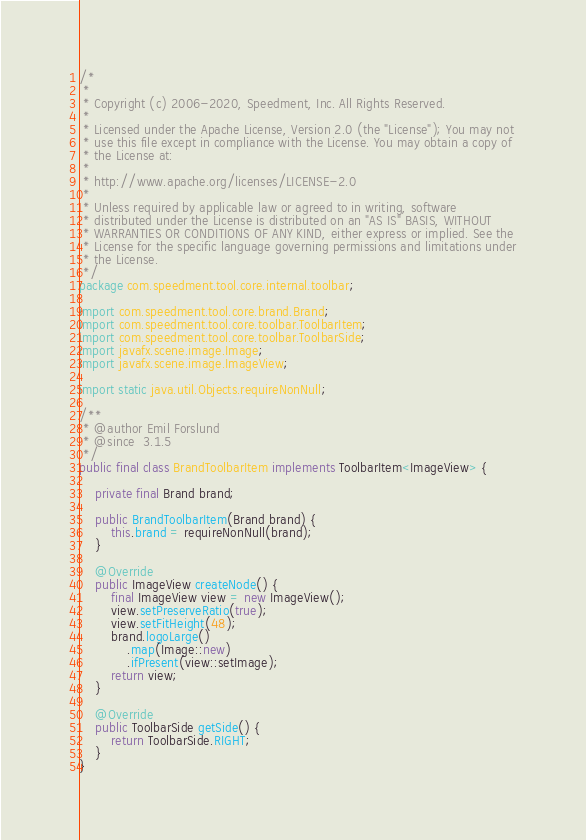<code> <loc_0><loc_0><loc_500><loc_500><_Java_>/*
 *
 * Copyright (c) 2006-2020, Speedment, Inc. All Rights Reserved.
 *
 * Licensed under the Apache License, Version 2.0 (the "License"); You may not
 * use this file except in compliance with the License. You may obtain a copy of
 * the License at:
 *
 * http://www.apache.org/licenses/LICENSE-2.0
 *
 * Unless required by applicable law or agreed to in writing, software
 * distributed under the License is distributed on an "AS IS" BASIS, WITHOUT
 * WARRANTIES OR CONDITIONS OF ANY KIND, either express or implied. See the
 * License for the specific language governing permissions and limitations under
 * the License.
 */
package com.speedment.tool.core.internal.toolbar;

import com.speedment.tool.core.brand.Brand;
import com.speedment.tool.core.toolbar.ToolbarItem;
import com.speedment.tool.core.toolbar.ToolbarSide;
import javafx.scene.image.Image;
import javafx.scene.image.ImageView;

import static java.util.Objects.requireNonNull;

/**
 * @author Emil Forslund
 * @since  3.1.5
 */
public final class BrandToolbarItem implements ToolbarItem<ImageView> {

    private final Brand brand;

    public BrandToolbarItem(Brand brand) {
        this.brand = requireNonNull(brand);
    }

    @Override
    public ImageView createNode() {
        final ImageView view = new ImageView();
        view.setPreserveRatio(true);
        view.setFitHeight(48);
        brand.logoLarge()
            .map(Image::new)
            .ifPresent(view::setImage);
        return view;
    }

    @Override
    public ToolbarSide getSide() {
        return ToolbarSide.RIGHT;
    }
}
</code> 